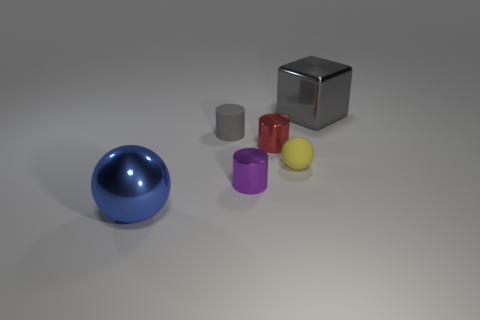The gray thing that is the same material as the small yellow object is what size? The gray object, which appears to be made of the same matte material as the small yellow cylindrical object, is medium in size compared to the other items present. It is larger than the yellow, purple, and red objects, but smaller than the blue sphere. 